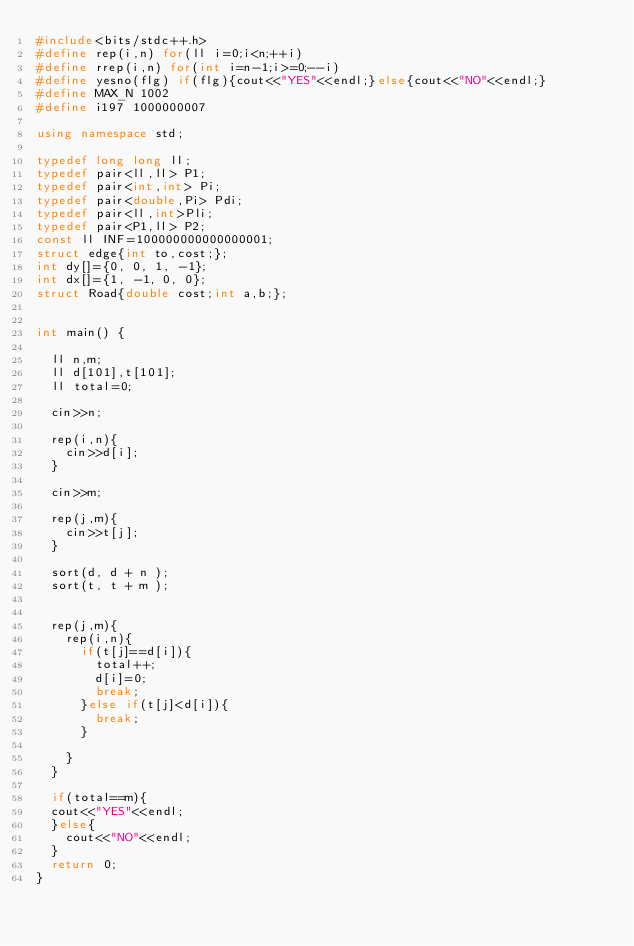<code> <loc_0><loc_0><loc_500><loc_500><_C++_>#include<bits/stdc++.h>
#define rep(i,n) for(ll i=0;i<n;++i)
#define rrep(i,n) for(int i=n-1;i>=0;--i)
#define yesno(flg) if(flg){cout<<"YES"<<endl;}else{cout<<"NO"<<endl;}
#define MAX_N 1002
#define i197 1000000007

using namespace std;

typedef long long ll;
typedef pair<ll,ll> P1;
typedef pair<int,int> Pi;
typedef pair<double,Pi> Pdi;
typedef pair<ll,int>Pli;
typedef pair<P1,ll> P2;
const ll INF=100000000000000001;
struct edge{int to,cost;};
int dy[]={0, 0, 1, -1};
int dx[]={1, -1, 0, 0};
struct Road{double cost;int a,b;};


int main() {

	ll n,m;
	ll d[101],t[101];
	ll total=0;

	cin>>n;

	rep(i,n){
		cin>>d[i];
	}

	cin>>m;

	rep(j,m){
		cin>>t[j];
	}

	sort(d, d + n );
	sort(t, t + m );


	rep(j,m){
		rep(i,n){
			if(t[j]==d[i]){
				total++;
				d[i]=0;
				break;
			}else if(t[j]<d[i]){
				break;
			}

		}
	}

	if(total==m){
	cout<<"YES"<<endl;
	}else{
		cout<<"NO"<<endl;
	}
	return 0;
}
</code> 